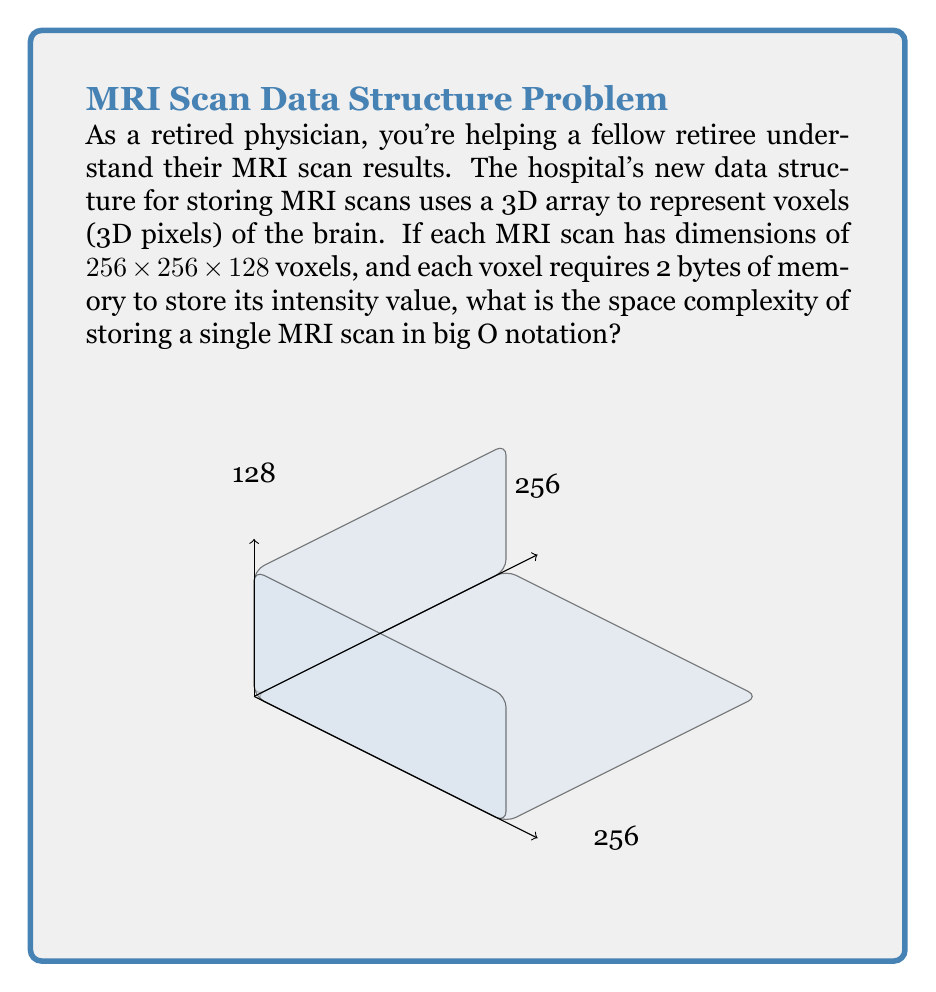Give your solution to this math problem. Let's break this down step-by-step:

1) First, we need to calculate the total number of voxels in the MRI scan:
   $$ \text{Total voxels} = 256 \times 256 \times 128 = 8,388,608 $$

2) Each voxel requires 2 bytes of memory:
   $$ \text{Memory per voxel} = 2 \text{ bytes} $$

3) Therefore, the total memory required for one MRI scan is:
   $$ \text{Total memory} = 8,388,608 \times 2 = 16,777,216 \text{ bytes} $$

4) This is equivalent to 16 MB (Megabytes).

5) In terms of space complexity, we're interested in how the memory usage grows with respect to the input size. In this case, the input size can be considered as the dimensions of the scan.

6) Let's say the dimensions are represented by $n$. Then the number of voxels (and consequently the memory usage) grows as $O(n^3)$, because it's proportional to the product of the three dimensions.

7) The constant factor (2 bytes per voxel) doesn't affect the big O notation.

Therefore, the space complexity for storing a single MRI scan with this data structure is $O(n^3)$, where $n$ represents the dimension size.
Answer: $O(n^3)$ 